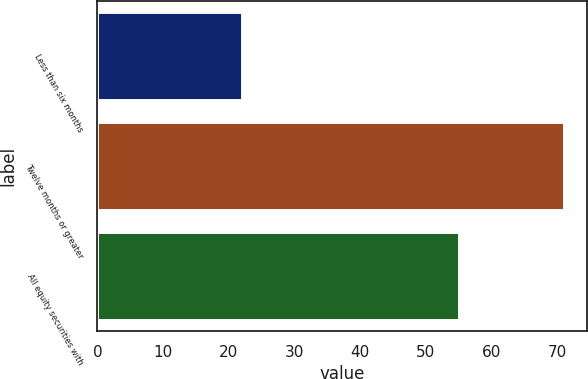Convert chart to OTSL. <chart><loc_0><loc_0><loc_500><loc_500><bar_chart><fcel>Less than six months<fcel>Twelve months or greater<fcel>All equity securities with<nl><fcel>22<fcel>71<fcel>55<nl></chart> 